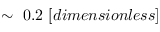Convert formula to latex. <formula><loc_0><loc_0><loc_500><loc_500>\sim \ 0 . 2 \ [ d i m e n s i o n l e s s ]</formula> 